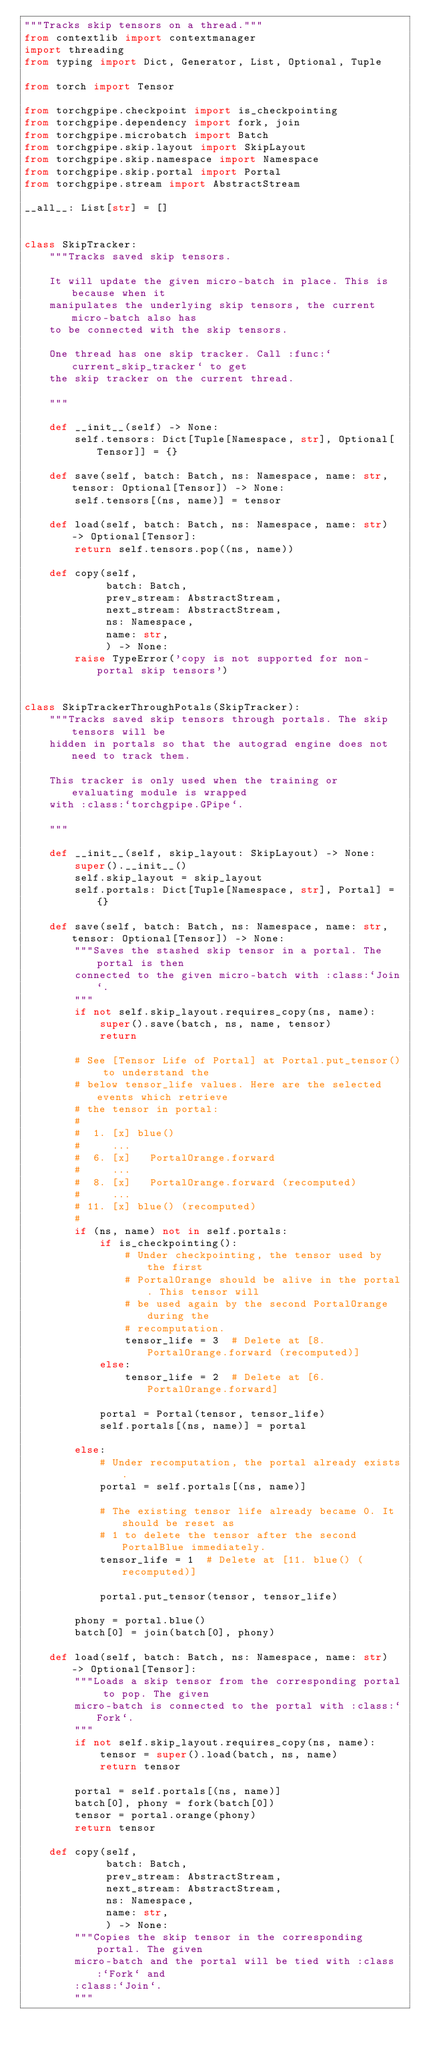<code> <loc_0><loc_0><loc_500><loc_500><_Python_>"""Tracks skip tensors on a thread."""
from contextlib import contextmanager
import threading
from typing import Dict, Generator, List, Optional, Tuple

from torch import Tensor

from torchgpipe.checkpoint import is_checkpointing
from torchgpipe.dependency import fork, join
from torchgpipe.microbatch import Batch
from torchgpipe.skip.layout import SkipLayout
from torchgpipe.skip.namespace import Namespace
from torchgpipe.skip.portal import Portal
from torchgpipe.stream import AbstractStream

__all__: List[str] = []


class SkipTracker:
    """Tracks saved skip tensors.

    It will update the given micro-batch in place. This is because when it
    manipulates the underlying skip tensors, the current micro-batch also has
    to be connected with the skip tensors.

    One thread has one skip tracker. Call :func:`current_skip_tracker` to get
    the skip tracker on the current thread.

    """

    def __init__(self) -> None:
        self.tensors: Dict[Tuple[Namespace, str], Optional[Tensor]] = {}

    def save(self, batch: Batch, ns: Namespace, name: str, tensor: Optional[Tensor]) -> None:
        self.tensors[(ns, name)] = tensor

    def load(self, batch: Batch, ns: Namespace, name: str) -> Optional[Tensor]:
        return self.tensors.pop((ns, name))

    def copy(self,
             batch: Batch,
             prev_stream: AbstractStream,
             next_stream: AbstractStream,
             ns: Namespace,
             name: str,
             ) -> None:
        raise TypeError('copy is not supported for non-portal skip tensors')


class SkipTrackerThroughPotals(SkipTracker):
    """Tracks saved skip tensors through portals. The skip tensors will be
    hidden in portals so that the autograd engine does not need to track them.

    This tracker is only used when the training or evaluating module is wrapped
    with :class:`torchgpipe.GPipe`.

    """

    def __init__(self, skip_layout: SkipLayout) -> None:
        super().__init__()
        self.skip_layout = skip_layout
        self.portals: Dict[Tuple[Namespace, str], Portal] = {}

    def save(self, batch: Batch, ns: Namespace, name: str, tensor: Optional[Tensor]) -> None:
        """Saves the stashed skip tensor in a portal. The portal is then
        connected to the given micro-batch with :class:`Join`.
        """
        if not self.skip_layout.requires_copy(ns, name):
            super().save(batch, ns, name, tensor)
            return

        # See [Tensor Life of Portal] at Portal.put_tensor() to understand the
        # below tensor_life values. Here are the selected events which retrieve
        # the tensor in portal:
        #
        #  1. [x] blue()
        #     ...
        #  6. [x]   PortalOrange.forward
        #     ...
        #  8. [x]   PortalOrange.forward (recomputed)
        #     ...
        # 11. [x] blue() (recomputed)
        #
        if (ns, name) not in self.portals:
            if is_checkpointing():
                # Under checkpointing, the tensor used by the first
                # PortalOrange should be alive in the portal. This tensor will
                # be used again by the second PortalOrange during the
                # recomputation.
                tensor_life = 3  # Delete at [8. PortalOrange.forward (recomputed)]
            else:
                tensor_life = 2  # Delete at [6. PortalOrange.forward]

            portal = Portal(tensor, tensor_life)
            self.portals[(ns, name)] = portal

        else:
            # Under recomputation, the portal already exists.
            portal = self.portals[(ns, name)]

            # The existing tensor life already became 0. It should be reset as
            # 1 to delete the tensor after the second PortalBlue immediately.
            tensor_life = 1  # Delete at [11. blue() (recomputed)]

            portal.put_tensor(tensor, tensor_life)

        phony = portal.blue()
        batch[0] = join(batch[0], phony)

    def load(self, batch: Batch, ns: Namespace, name: str) -> Optional[Tensor]:
        """Loads a skip tensor from the corresponding portal to pop. The given
        micro-batch is connected to the portal with :class:`Fork`.
        """
        if not self.skip_layout.requires_copy(ns, name):
            tensor = super().load(batch, ns, name)
            return tensor

        portal = self.portals[(ns, name)]
        batch[0], phony = fork(batch[0])
        tensor = portal.orange(phony)
        return tensor

    def copy(self,
             batch: Batch,
             prev_stream: AbstractStream,
             next_stream: AbstractStream,
             ns: Namespace,
             name: str,
             ) -> None:
        """Copies the skip tensor in the corresponding portal. The given
        micro-batch and the portal will be tied with :class:`Fork` and
        :class:`Join`.
        """</code> 